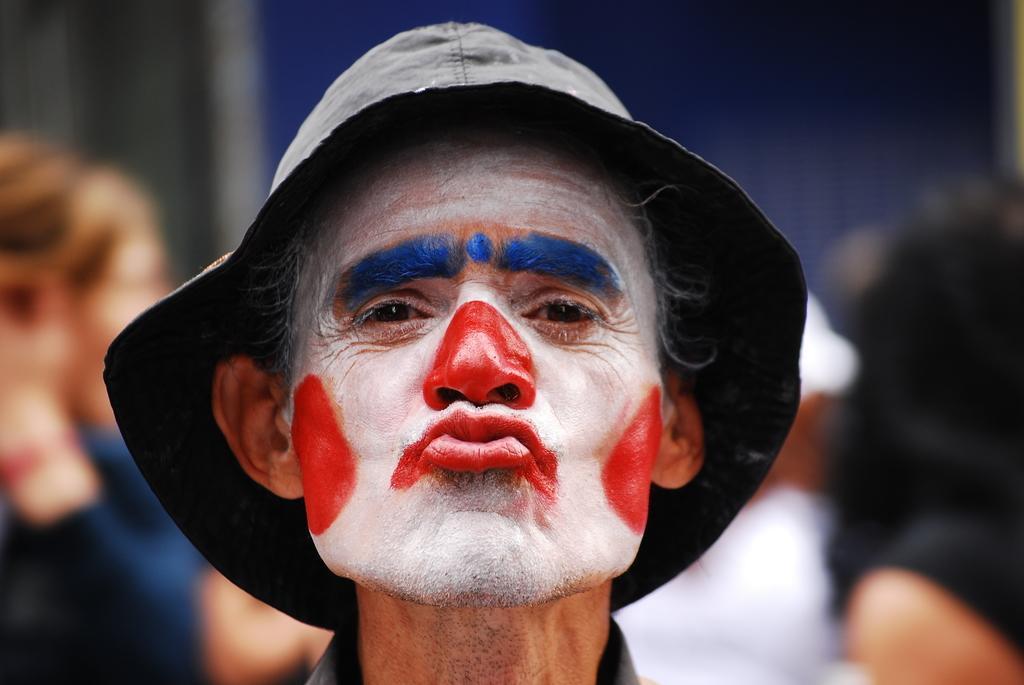Could you give a brief overview of what you see in this image? In the foreground of the image there is a person wearing a cap. In the background of the image there are people. 